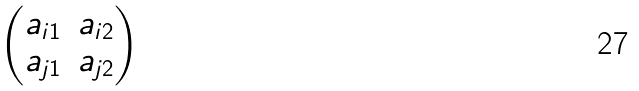Convert formula to latex. <formula><loc_0><loc_0><loc_500><loc_500>\begin{pmatrix} a _ { i 1 } & a _ { i 2 } \\ a _ { j 1 } & a _ { j 2 } \end{pmatrix}</formula> 